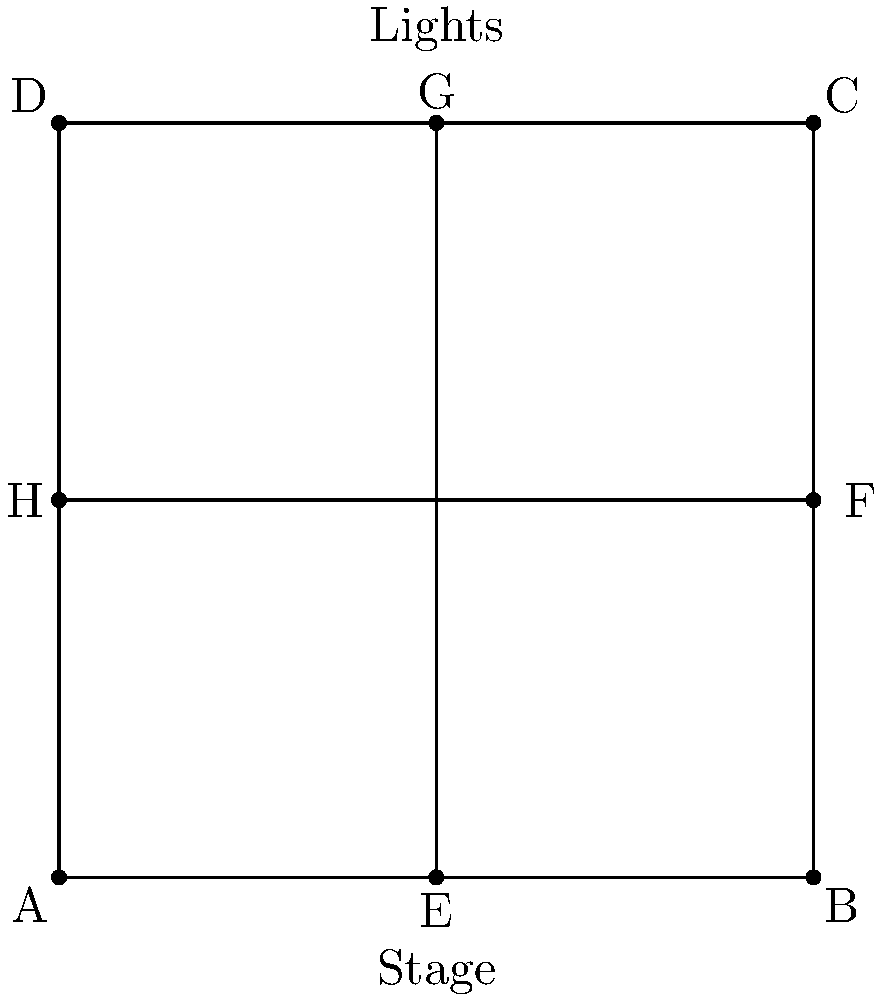In designing a stage layout for Primal Scream's upcoming tour, you're experimenting with reflectional symmetry for the lighting arrangement. The stage is represented by the square ABCD, with lights positioned at points E, F, G, and H. If light H is reflected across the line EG, where will its image be located? To solve this problem, we need to understand the properties of reflectional symmetry:

1. The line of reflection (EG in this case) acts as a mirror.
2. The distance from a point to the line of reflection is equal to the distance from its image to the line of reflection.
3. The line connecting a point to its image is perpendicular to the line of reflection.

Let's follow these steps:

1. Identify the line of reflection: EG connects opposite midpoints of the square.

2. Observe that EG divides the square into two equal triangles.

3. Point H is located at the midpoint of side AD.

4. Due to the symmetry of the square, the reflection of H across EG must be at the midpoint of the opposite side, BC.

5. The midpoint of BC is point F.

Therefore, when light H is reflected across line EG, its image will be at point F.

This reflection creates a balanced and symmetrical lighting design, which is often used in stage setups to create visual harmony and enhance the overall aesthetic of the performance space.
Answer: F 